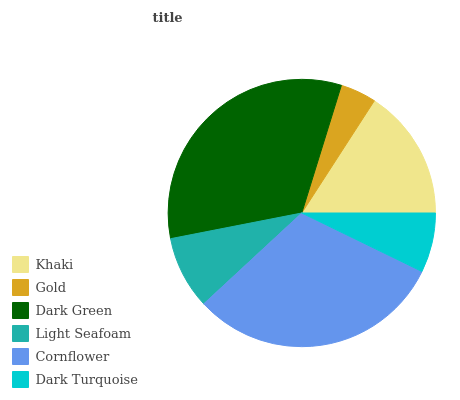Is Gold the minimum?
Answer yes or no. Yes. Is Dark Green the maximum?
Answer yes or no. Yes. Is Dark Green the minimum?
Answer yes or no. No. Is Gold the maximum?
Answer yes or no. No. Is Dark Green greater than Gold?
Answer yes or no. Yes. Is Gold less than Dark Green?
Answer yes or no. Yes. Is Gold greater than Dark Green?
Answer yes or no. No. Is Dark Green less than Gold?
Answer yes or no. No. Is Khaki the high median?
Answer yes or no. Yes. Is Light Seafoam the low median?
Answer yes or no. Yes. Is Cornflower the high median?
Answer yes or no. No. Is Cornflower the low median?
Answer yes or no. No. 